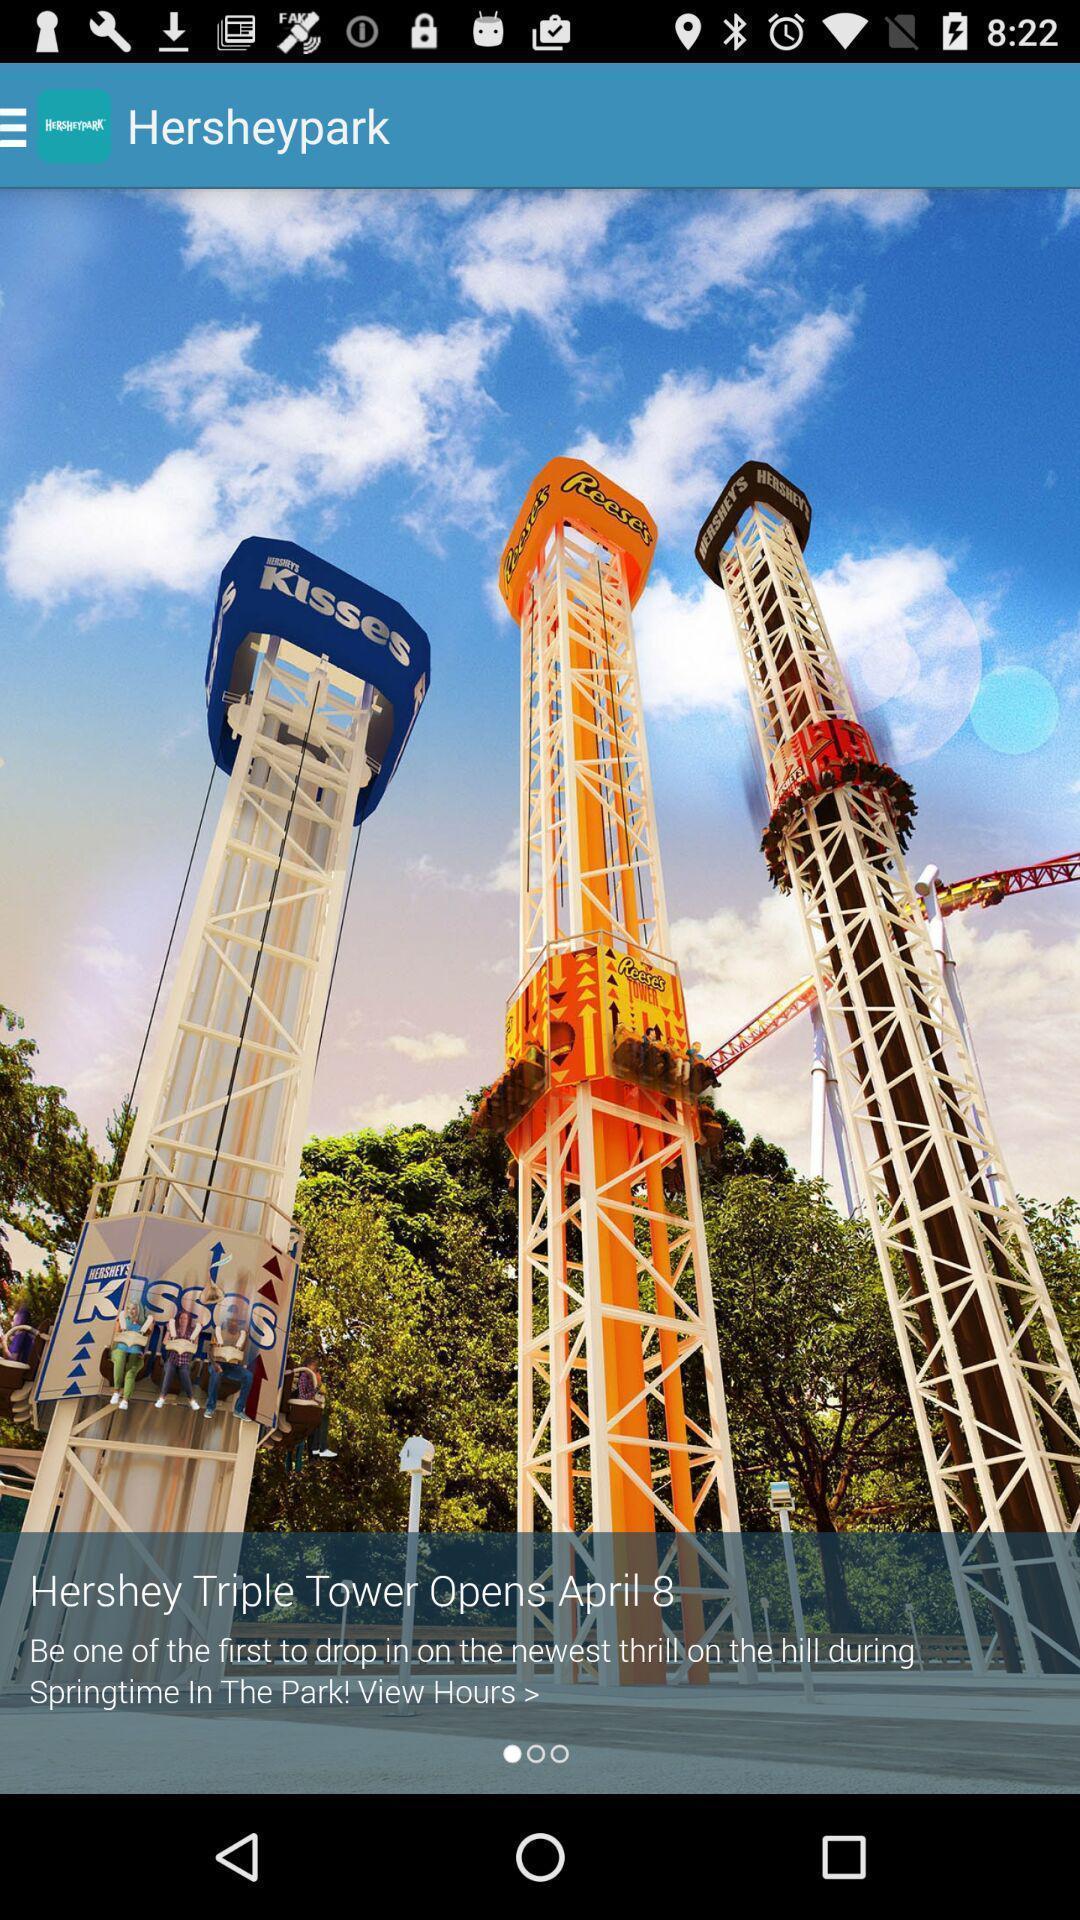Explain what's happening in this screen capture. Screen shows beginning page. 